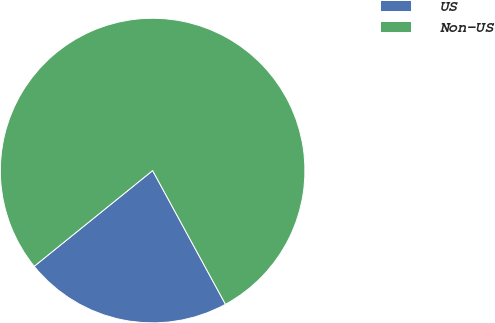<chart> <loc_0><loc_0><loc_500><loc_500><pie_chart><fcel>US<fcel>Non-US<nl><fcel>22.12%<fcel>77.88%<nl></chart> 